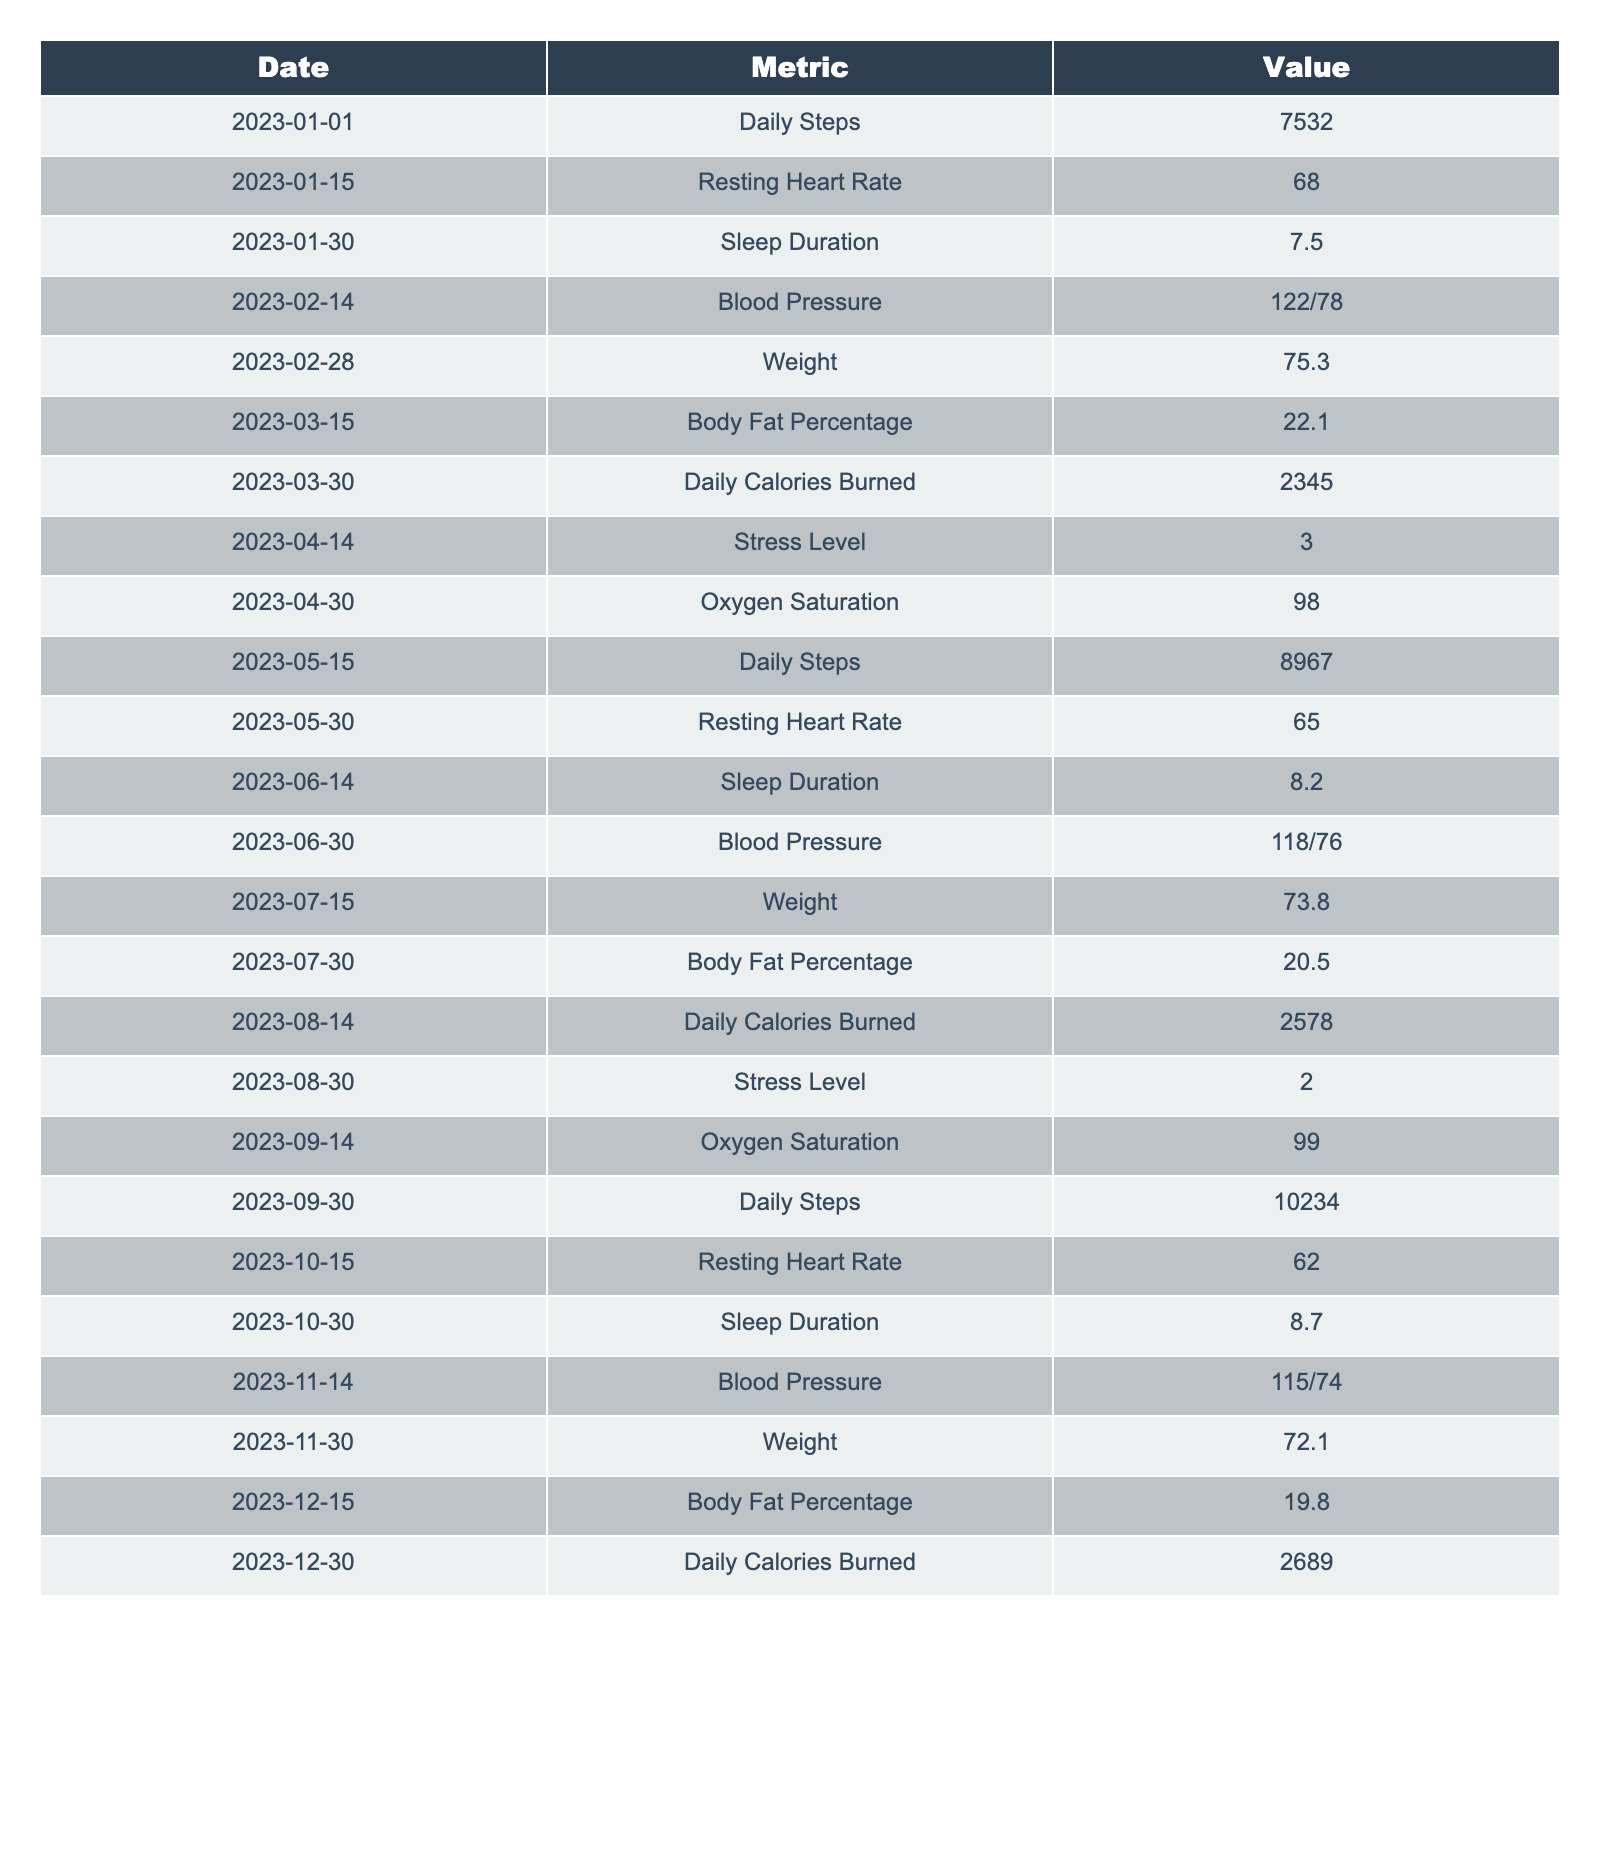What was the highest recorded daily step count? The maximum daily step count can be found by looking through the "Daily Steps" entries. The highest value is 10,234 on 2023-09-30.
Answer: 10,234 What is the average resting heart rate over the year? We take the resting heart rates recorded on 2023-01-15 (68), 2023-05-30 (65), 2023-10-15 (62). Summing these gives 68 + 65 + 62 = 195. Dividing by 3 (the number of entries) results in an average resting heart rate of 65.
Answer: 65 Did the daily step count increase from January to December? By comparing the daily step counts in January (7,532) and December (which does not have an entry for daily steps), we cannot definitively answer as December data is missing.
Answer: No What was the change in weight from the beginning of the year to the end? The weight on 2023-01-30 was 75.3 kg and on 2023-12-30 it was 72.1 kg. The change in weight is calculated as 75.3 - 72.1 = 3.2 kg. Thus, there was a weight loss of 3.2 kg.
Answer: 3.2 kg What was the number of days with stress levels below 3? We look for entries with stress levels below 3 which are on 2023-04-14 (3) and 2023-08-30 (2). The only entry below 3 is on 2023-08-30. Thus, there is 1 day below the threshold.
Answer: 1 What is the trend of body fat percentage throughout the year? The body fat percentage measurements are 22.1 (March), 20.5 (July), and 19.8 (December). Observing these values shows a clear decrease over time, indicating an improving trend.
Answer: Decreasing Which month had the highest daily calories burned? By comparing the entries for daily calories burned, March shows 2,345, August shows 2,578, and December shows 2,689. The highest value recorded is in December at 2,689 calories.
Answer: December How does sleep duration correlate with resting heart rate in this data? The sleep durations to compare are: 7.5 hours on 2023-01-30 (resting HR 68), 8.2 hours on 2023-06-14 (HR 65), and 8.7 hours on 2023-10-30 (HR 62). Higher sleep durations correspond with lower resting heart rates, indicating a negative correlation.
Answer: Negative correlation Was there a consistent improvement in blood pressure readings over the year? Reviewing the blood pressure entries: 122/78 (February), then 118/76 (June), and 115/74 (November). Each subsequent measurement shows a decrease, indicating a consistent improvement in blood pressure.
Answer: Yes What was the maximum oxygen saturation recorded? The recorded oxygen saturation values are 98 on 2023-04-30 and 99 on 2023-09-14. Therefore, the maximum recorded oxygen saturation is 99.
Answer: 99 How many metrics showed improvement from their starting value by the end of the year? Metrics with starting values are weight (75.3 kg to 72.1 kg), body fat (22.1% to 19.8%), resting heart rate (68 to 62), and stress level (3 to 2). Thus, out of metrics tracked, four showed improvement.
Answer: 4 